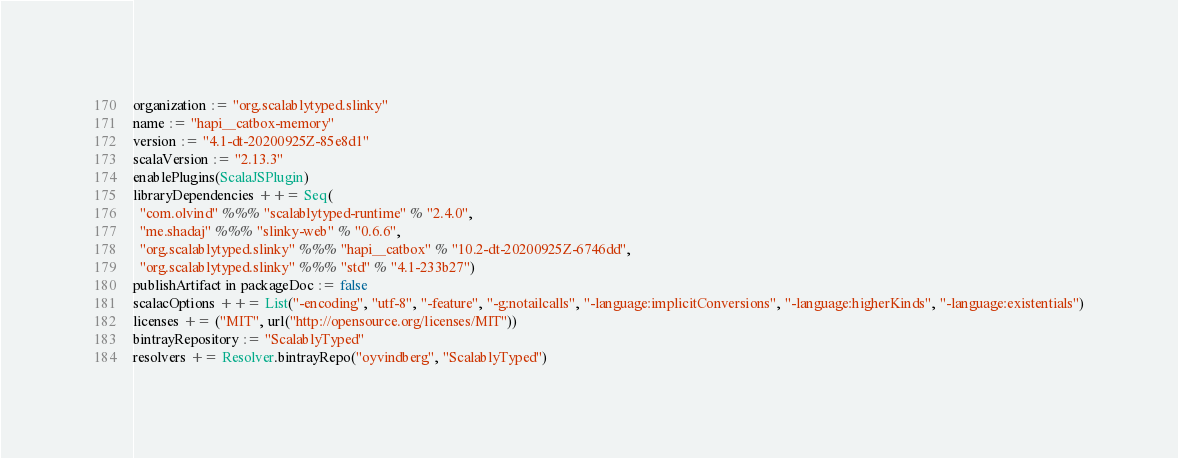Convert code to text. <code><loc_0><loc_0><loc_500><loc_500><_Scala_>organization := "org.scalablytyped.slinky"
name := "hapi__catbox-memory"
version := "4.1-dt-20200925Z-85e8d1"
scalaVersion := "2.13.3"
enablePlugins(ScalaJSPlugin)
libraryDependencies ++= Seq(
  "com.olvind" %%% "scalablytyped-runtime" % "2.4.0",
  "me.shadaj" %%% "slinky-web" % "0.6.6",
  "org.scalablytyped.slinky" %%% "hapi__catbox" % "10.2-dt-20200925Z-6746dd",
  "org.scalablytyped.slinky" %%% "std" % "4.1-233b27")
publishArtifact in packageDoc := false
scalacOptions ++= List("-encoding", "utf-8", "-feature", "-g:notailcalls", "-language:implicitConversions", "-language:higherKinds", "-language:existentials")
licenses += ("MIT", url("http://opensource.org/licenses/MIT"))
bintrayRepository := "ScalablyTyped"
resolvers += Resolver.bintrayRepo("oyvindberg", "ScalablyTyped")
</code> 